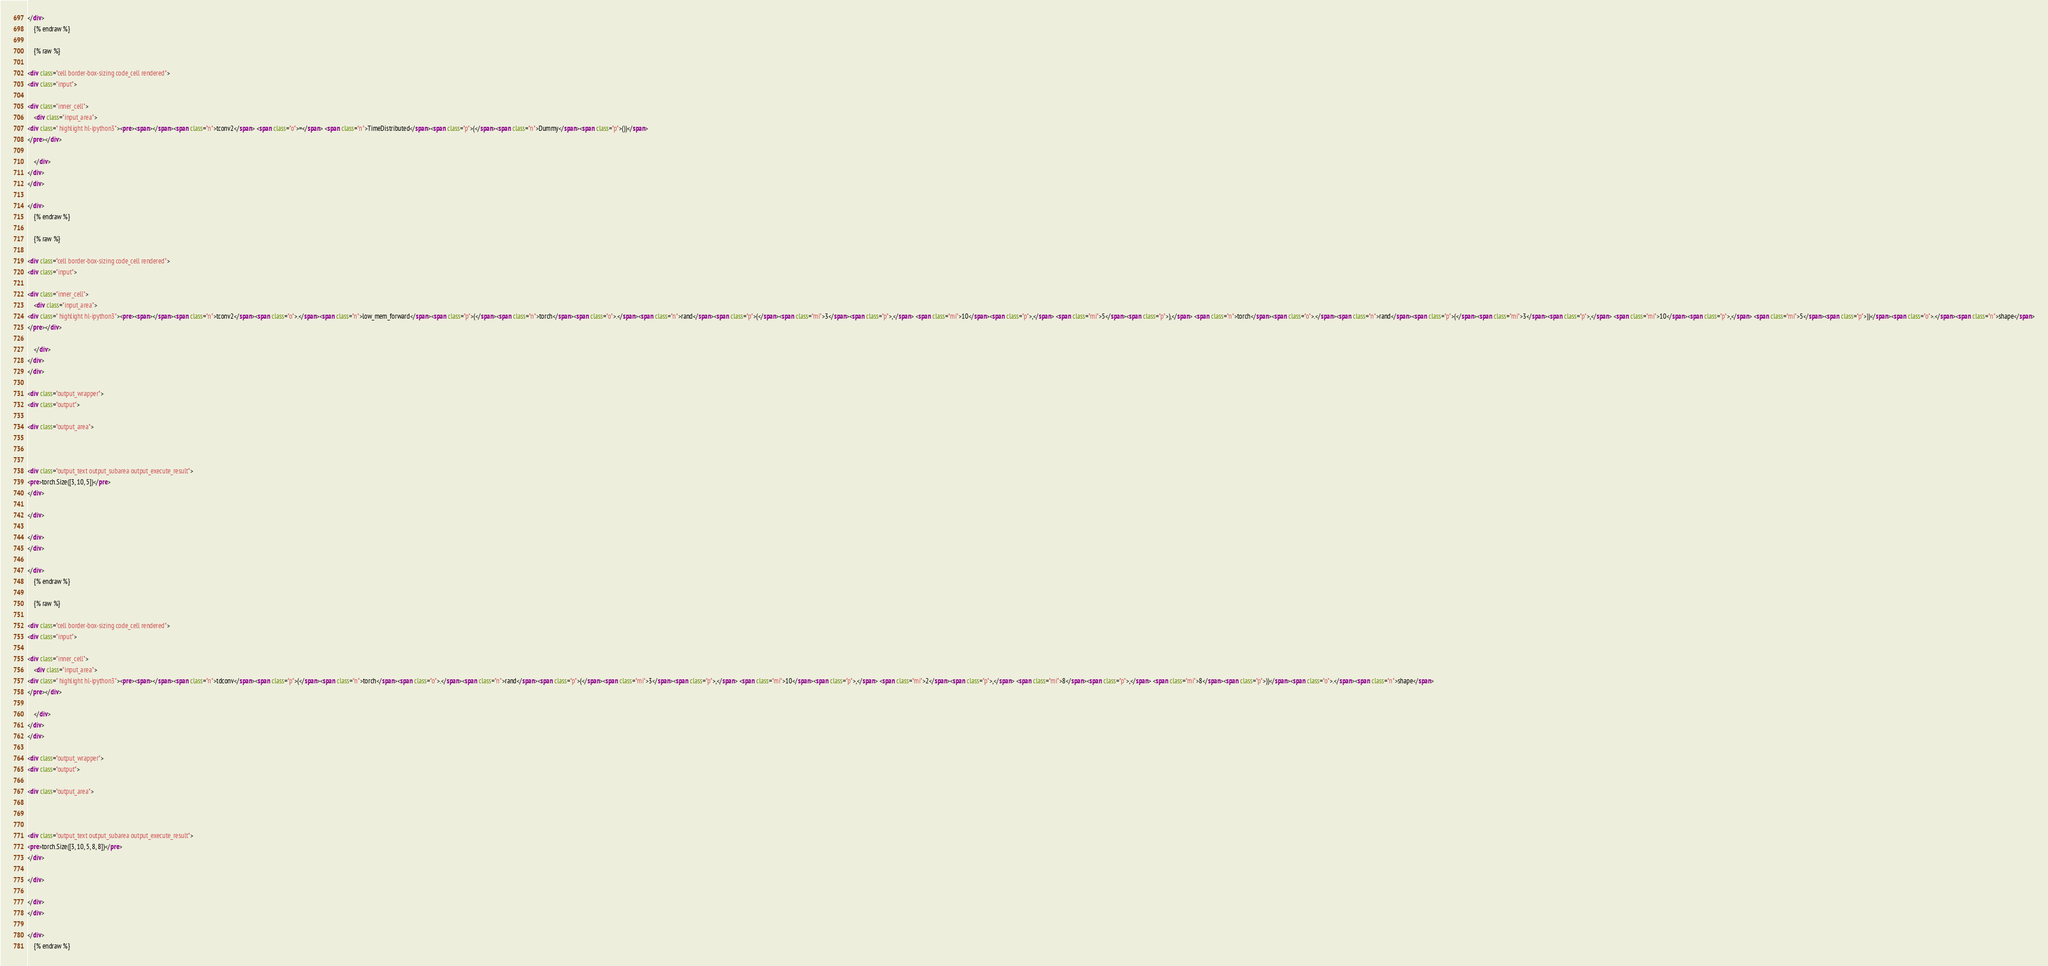Convert code to text. <code><loc_0><loc_0><loc_500><loc_500><_HTML_></div>
    {% endraw %}

    {% raw %}
    
<div class="cell border-box-sizing code_cell rendered">
<div class="input">

<div class="inner_cell">
    <div class="input_area">
<div class=" highlight hl-ipython3"><pre><span></span><span class="n">tconv2</span> <span class="o">=</span> <span class="n">TimeDistributed</span><span class="p">(</span><span class="n">Dummy</span><span class="p">())</span>
</pre></div>

    </div>
</div>
</div>

</div>
    {% endraw %}

    {% raw %}
    
<div class="cell border-box-sizing code_cell rendered">
<div class="input">

<div class="inner_cell">
    <div class="input_area">
<div class=" highlight hl-ipython3"><pre><span></span><span class="n">tconv2</span><span class="o">.</span><span class="n">low_mem_forward</span><span class="p">(</span><span class="n">torch</span><span class="o">.</span><span class="n">rand</span><span class="p">(</span><span class="mi">3</span><span class="p">,</span> <span class="mi">10</span><span class="p">,</span> <span class="mi">5</span><span class="p">),</span> <span class="n">torch</span><span class="o">.</span><span class="n">rand</span><span class="p">(</span><span class="mi">3</span><span class="p">,</span> <span class="mi">10</span><span class="p">,</span> <span class="mi">5</span><span class="p">))</span><span class="o">.</span><span class="n">shape</span>
</pre></div>

    </div>
</div>
</div>

<div class="output_wrapper">
<div class="output">

<div class="output_area">



<div class="output_text output_subarea output_execute_result">
<pre>torch.Size([3, 10, 5])</pre>
</div>

</div>

</div>
</div>

</div>
    {% endraw %}

    {% raw %}
    
<div class="cell border-box-sizing code_cell rendered">
<div class="input">

<div class="inner_cell">
    <div class="input_area">
<div class=" highlight hl-ipython3"><pre><span></span><span class="n">tdconv</span><span class="p">(</span><span class="n">torch</span><span class="o">.</span><span class="n">rand</span><span class="p">(</span><span class="mi">3</span><span class="p">,</span> <span class="mi">10</span><span class="p">,</span> <span class="mi">2</span><span class="p">,</span> <span class="mi">8</span><span class="p">,</span> <span class="mi">8</span><span class="p">))</span><span class="o">.</span><span class="n">shape</span>
</pre></div>

    </div>
</div>
</div>

<div class="output_wrapper">
<div class="output">

<div class="output_area">



<div class="output_text output_subarea output_execute_result">
<pre>torch.Size([3, 10, 5, 8, 8])</pre>
</div>

</div>

</div>
</div>

</div>
    {% endraw %}
</code> 